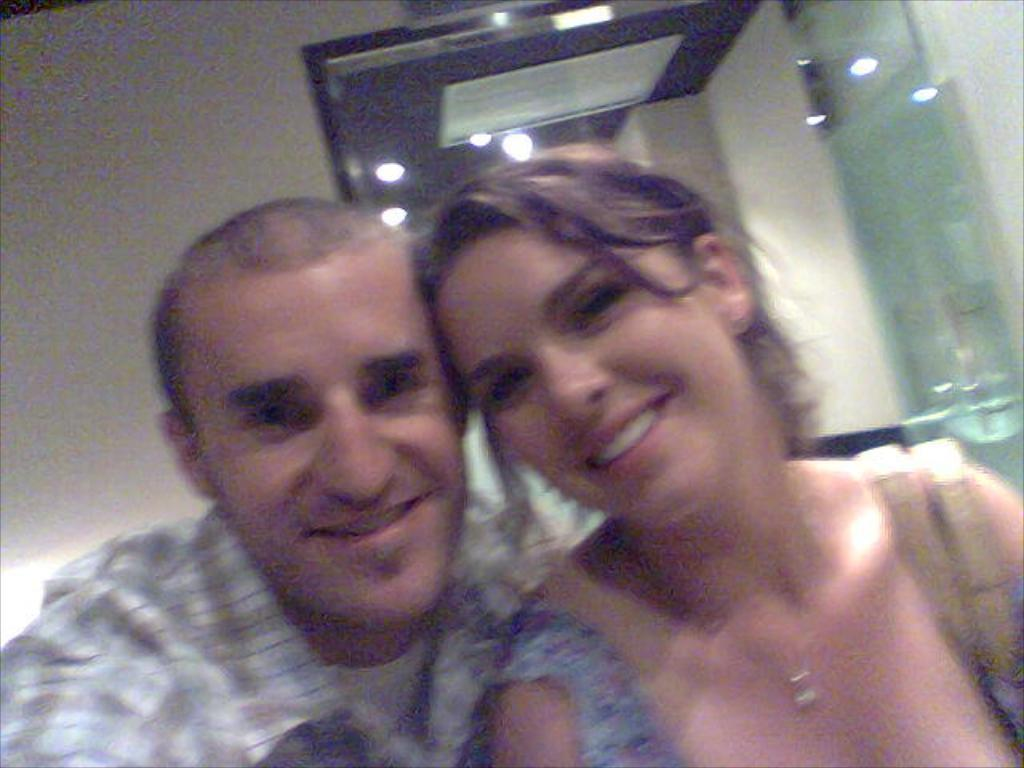Who is present in the image? There is a man and a woman in the image. What are the facial expressions of the people in the image? Both the man and the woman are smiling in the image. What object can be seen in the image that might be used for personal grooming or reflection? There is a mirror in the image. How many chairs are visible in the image? There are no chairs present in the image. What type of canvas is being used by the man in the image? There is no canvas present in the image, and the man is not depicted as using one. 